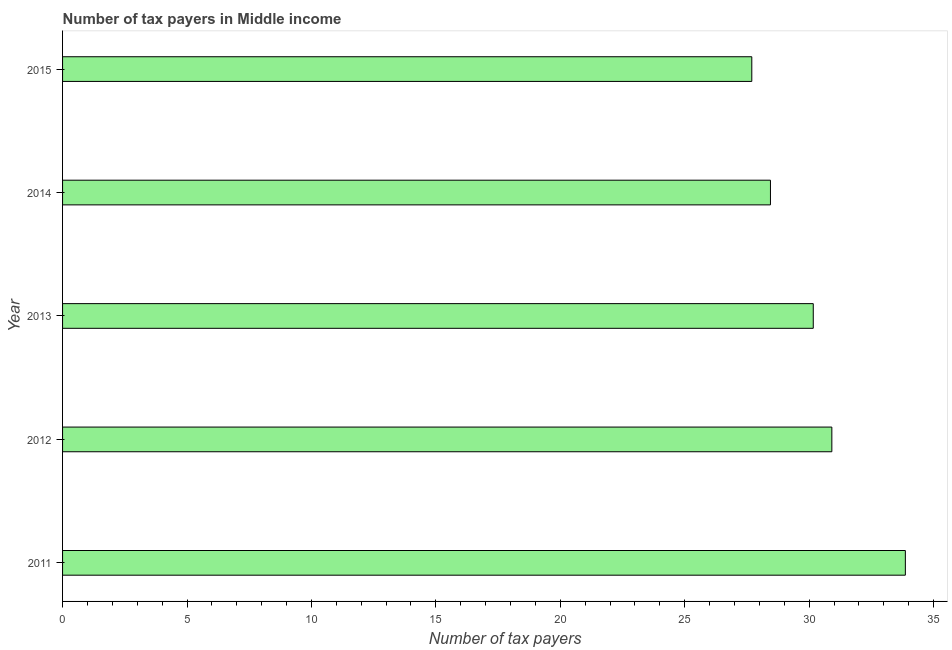Does the graph contain grids?
Make the answer very short. No. What is the title of the graph?
Offer a very short reply. Number of tax payers in Middle income. What is the label or title of the X-axis?
Your response must be concise. Number of tax payers. What is the label or title of the Y-axis?
Your answer should be compact. Year. What is the number of tax payers in 2011?
Provide a succinct answer. 33.87. Across all years, what is the maximum number of tax payers?
Ensure brevity in your answer.  33.87. Across all years, what is the minimum number of tax payers?
Your response must be concise. 27.7. In which year was the number of tax payers maximum?
Your answer should be compact. 2011. In which year was the number of tax payers minimum?
Provide a short and direct response. 2015. What is the sum of the number of tax payers?
Keep it short and to the point. 151.09. What is the difference between the number of tax payers in 2014 and 2015?
Provide a succinct answer. 0.75. What is the average number of tax payers per year?
Offer a terse response. 30.22. What is the median number of tax payers?
Provide a succinct answer. 30.17. Do a majority of the years between 2011 and 2012 (inclusive) have number of tax payers greater than 22 ?
Offer a terse response. Yes. What is the ratio of the number of tax payers in 2011 to that in 2015?
Your response must be concise. 1.22. Is the difference between the number of tax payers in 2013 and 2014 greater than the difference between any two years?
Offer a terse response. No. What is the difference between the highest and the second highest number of tax payers?
Ensure brevity in your answer.  2.95. Is the sum of the number of tax payers in 2014 and 2015 greater than the maximum number of tax payers across all years?
Offer a very short reply. Yes. What is the difference between the highest and the lowest number of tax payers?
Offer a terse response. 6.17. In how many years, is the number of tax payers greater than the average number of tax payers taken over all years?
Offer a terse response. 2. Are all the bars in the graph horizontal?
Keep it short and to the point. Yes. What is the difference between two consecutive major ticks on the X-axis?
Provide a short and direct response. 5. What is the Number of tax payers in 2011?
Keep it short and to the point. 33.87. What is the Number of tax payers in 2012?
Give a very brief answer. 30.91. What is the Number of tax payers in 2013?
Your answer should be compact. 30.17. What is the Number of tax payers in 2014?
Your answer should be compact. 28.45. What is the Number of tax payers of 2015?
Your answer should be very brief. 27.7. What is the difference between the Number of tax payers in 2011 and 2012?
Provide a succinct answer. 2.95. What is the difference between the Number of tax payers in 2011 and 2013?
Provide a short and direct response. 3.7. What is the difference between the Number of tax payers in 2011 and 2014?
Ensure brevity in your answer.  5.42. What is the difference between the Number of tax payers in 2011 and 2015?
Make the answer very short. 6.17. What is the difference between the Number of tax payers in 2012 and 2013?
Keep it short and to the point. 0.75. What is the difference between the Number of tax payers in 2012 and 2014?
Offer a very short reply. 2.47. What is the difference between the Number of tax payers in 2012 and 2015?
Your answer should be very brief. 3.22. What is the difference between the Number of tax payers in 2013 and 2014?
Offer a terse response. 1.72. What is the difference between the Number of tax payers in 2013 and 2015?
Provide a short and direct response. 2.47. What is the ratio of the Number of tax payers in 2011 to that in 2012?
Ensure brevity in your answer.  1.1. What is the ratio of the Number of tax payers in 2011 to that in 2013?
Offer a very short reply. 1.12. What is the ratio of the Number of tax payers in 2011 to that in 2014?
Offer a terse response. 1.19. What is the ratio of the Number of tax payers in 2011 to that in 2015?
Ensure brevity in your answer.  1.22. What is the ratio of the Number of tax payers in 2012 to that in 2013?
Give a very brief answer. 1.02. What is the ratio of the Number of tax payers in 2012 to that in 2014?
Provide a succinct answer. 1.09. What is the ratio of the Number of tax payers in 2012 to that in 2015?
Keep it short and to the point. 1.12. What is the ratio of the Number of tax payers in 2013 to that in 2014?
Your answer should be very brief. 1.06. What is the ratio of the Number of tax payers in 2013 to that in 2015?
Give a very brief answer. 1.09. 